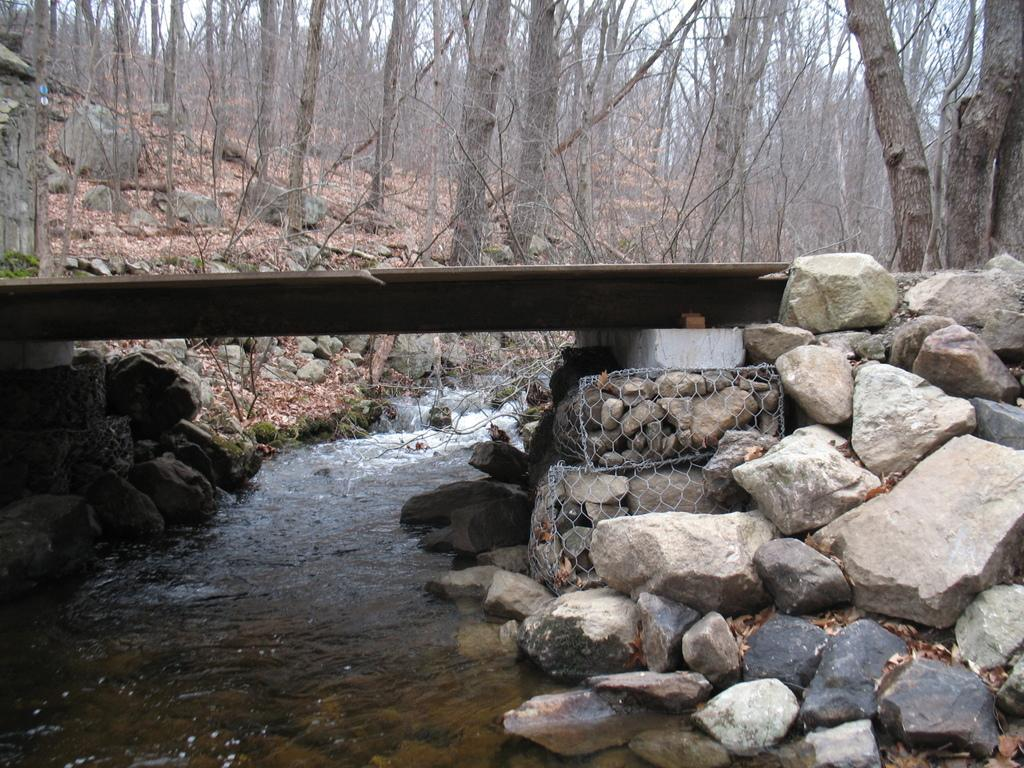What is the main feature in the middle of the image? There is a canal in the middle of the image. What structures are present above the canal? There are bridges above the canal on either side. What type of land is near the canal? There is rock land near the canal. What can be seen in the background of the image? Trees are visible in the background of the image. What time of day is it in the image, and how can you tell? The time of day cannot be determined from the image, as there are no clues such as shadows or lighting to indicate morning or any other time of day. 